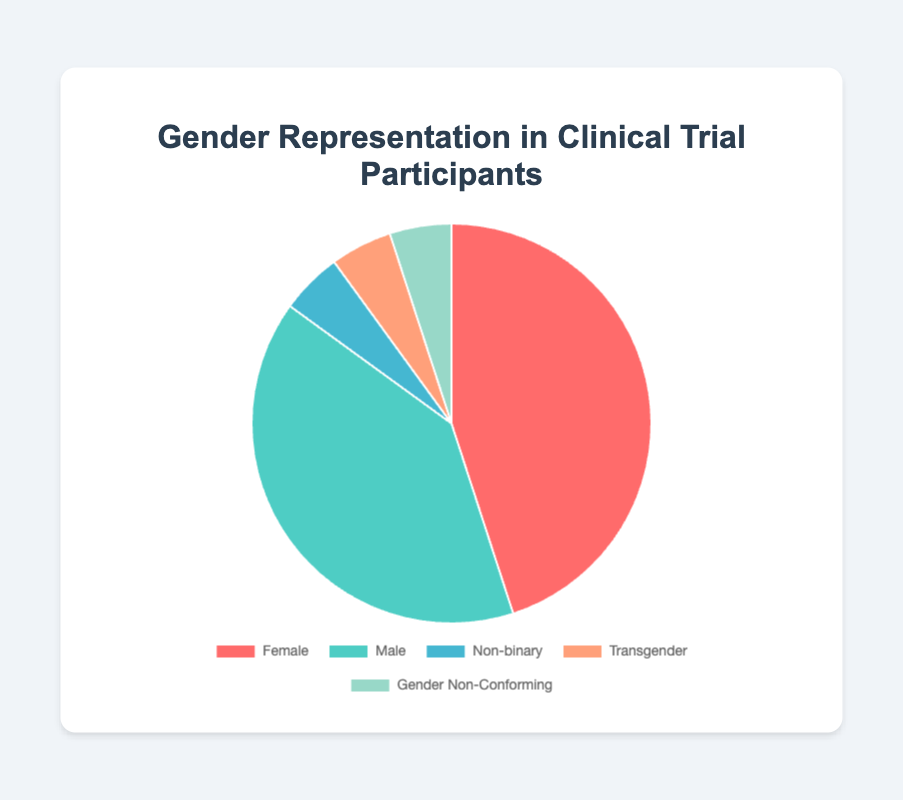What percentage of clinical trial participants identify as Female? By looking at the chart, the section represented by "Female" is marked with a distinct color and the corresponding percentage is labeled as 45%.
Answer: 45% Which gender category has the smallest representation in the clinical trial? According to the chart, the categories "Non-binary," "Transgender," and "Gender Non-Conforming" each have the smallest representation with 5% each.
Answer: Non-binary, Transgender, and Gender Non-Conforming How much higher is the representation of Female participants compared to Male participants? The percentage for Female is 45%, and for Male, it is 40%. The difference is obtained by subtracting the percentage for Male from the percentage for Female: 45% - 40% = 5%.
Answer: 5% What is the total percentage of participants who are either Non-binary, Transgender, or Gender Non-Conforming? Sum the percentages of Non-binary (5%), Transgender (5%), and Gender Non-Conforming (5%): 5% + 5% + 5% = 15%.
Answer: 15% Is the percentage of Male participants greater than the combined percentage of Non-binary, Transgender, and Gender Non-Conforming participants? The percentage of Male participants is 40%. The combined percentage of Non-binary, Transgender, and Gender Non-Conforming is 5% + 5% + 5% = 15%. Since 40% is greater than 15%, the answer is yes.
Answer: Yes Which gender category has a green-colored segment in the pie chart? The green-colored segment in the chart represents the Male category as evident from its placement and color-coding.
Answer: Male Compare the combined representation of Female and Male participants to the rest. Is it greater, less, or equal? The combined percentage of Female and Male participants is 45% + 40% = 85%. The remaining categories make up 15%. Hence, the combined representation of Female and Male (85%) is greater than the rest (15%).
Answer: Greater What percentage of the participants belong to gender categories other than Male or Female? The other categories include Non-binary (5%), Transgender (5%), and Gender Non-Conforming (5%), summing these up: 5% + 5% + 5% = 15%.
Answer: 15% 